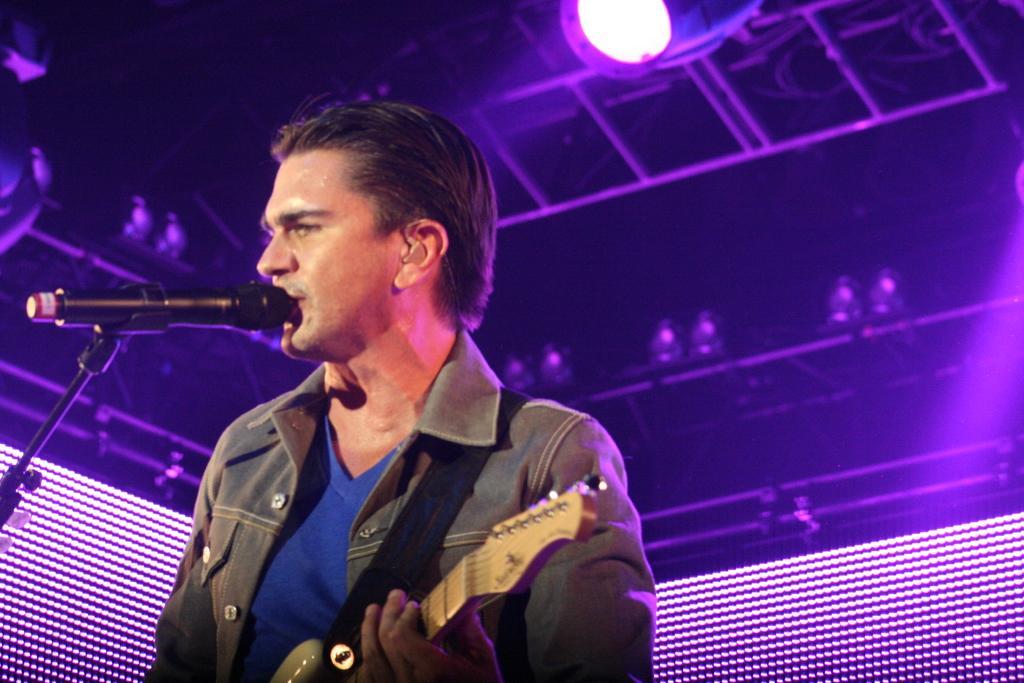Describe this image in one or two sentences. This picture describes a man is singing with the help of microphone, and he is playing guitar, in the background we can see a light and metal rods. 